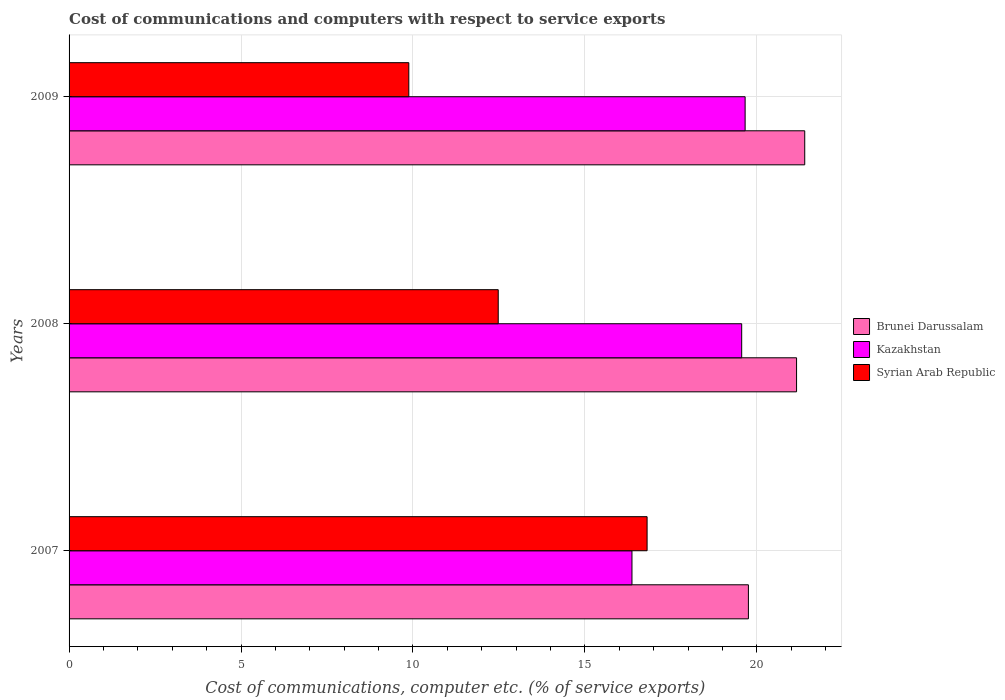Are the number of bars per tick equal to the number of legend labels?
Provide a succinct answer. Yes. Are the number of bars on each tick of the Y-axis equal?
Offer a terse response. Yes. How many bars are there on the 1st tick from the top?
Keep it short and to the point. 3. What is the label of the 3rd group of bars from the top?
Your answer should be very brief. 2007. What is the cost of communications and computers in Kazakhstan in 2009?
Your answer should be compact. 19.66. Across all years, what is the maximum cost of communications and computers in Syrian Arab Republic?
Your answer should be compact. 16.81. Across all years, what is the minimum cost of communications and computers in Brunei Darussalam?
Your answer should be very brief. 19.75. In which year was the cost of communications and computers in Kazakhstan maximum?
Offer a very short reply. 2009. What is the total cost of communications and computers in Brunei Darussalam in the graph?
Give a very brief answer. 62.3. What is the difference between the cost of communications and computers in Brunei Darussalam in 2007 and that in 2008?
Ensure brevity in your answer.  -1.4. What is the difference between the cost of communications and computers in Brunei Darussalam in 2009 and the cost of communications and computers in Syrian Arab Republic in 2008?
Make the answer very short. 8.91. What is the average cost of communications and computers in Kazakhstan per year?
Keep it short and to the point. 18.53. In the year 2009, what is the difference between the cost of communications and computers in Brunei Darussalam and cost of communications and computers in Kazakhstan?
Give a very brief answer. 1.73. What is the ratio of the cost of communications and computers in Brunei Darussalam in 2007 to that in 2008?
Provide a short and direct response. 0.93. What is the difference between the highest and the second highest cost of communications and computers in Syrian Arab Republic?
Provide a short and direct response. 4.33. What is the difference between the highest and the lowest cost of communications and computers in Brunei Darussalam?
Give a very brief answer. 1.64. What does the 3rd bar from the top in 2007 represents?
Offer a very short reply. Brunei Darussalam. What does the 3rd bar from the bottom in 2007 represents?
Provide a short and direct response. Syrian Arab Republic. How many bars are there?
Make the answer very short. 9. How many years are there in the graph?
Your answer should be compact. 3. What is the difference between two consecutive major ticks on the X-axis?
Your answer should be compact. 5. Are the values on the major ticks of X-axis written in scientific E-notation?
Offer a very short reply. No. Does the graph contain grids?
Your answer should be compact. Yes. How many legend labels are there?
Make the answer very short. 3. How are the legend labels stacked?
Ensure brevity in your answer.  Vertical. What is the title of the graph?
Give a very brief answer. Cost of communications and computers with respect to service exports. What is the label or title of the X-axis?
Your answer should be very brief. Cost of communications, computer etc. (% of service exports). What is the label or title of the Y-axis?
Offer a terse response. Years. What is the Cost of communications, computer etc. (% of service exports) in Brunei Darussalam in 2007?
Provide a short and direct response. 19.75. What is the Cost of communications, computer etc. (% of service exports) of Kazakhstan in 2007?
Provide a short and direct response. 16.37. What is the Cost of communications, computer etc. (% of service exports) of Syrian Arab Republic in 2007?
Your answer should be very brief. 16.81. What is the Cost of communications, computer etc. (% of service exports) of Brunei Darussalam in 2008?
Offer a terse response. 21.15. What is the Cost of communications, computer etc. (% of service exports) of Kazakhstan in 2008?
Your response must be concise. 19.56. What is the Cost of communications, computer etc. (% of service exports) in Syrian Arab Republic in 2008?
Provide a short and direct response. 12.48. What is the Cost of communications, computer etc. (% of service exports) of Brunei Darussalam in 2009?
Give a very brief answer. 21.39. What is the Cost of communications, computer etc. (% of service exports) of Kazakhstan in 2009?
Provide a succinct answer. 19.66. What is the Cost of communications, computer etc. (% of service exports) in Syrian Arab Republic in 2009?
Keep it short and to the point. 9.88. Across all years, what is the maximum Cost of communications, computer etc. (% of service exports) of Brunei Darussalam?
Make the answer very short. 21.39. Across all years, what is the maximum Cost of communications, computer etc. (% of service exports) in Kazakhstan?
Provide a short and direct response. 19.66. Across all years, what is the maximum Cost of communications, computer etc. (% of service exports) in Syrian Arab Republic?
Your answer should be very brief. 16.81. Across all years, what is the minimum Cost of communications, computer etc. (% of service exports) in Brunei Darussalam?
Offer a terse response. 19.75. Across all years, what is the minimum Cost of communications, computer etc. (% of service exports) in Kazakhstan?
Make the answer very short. 16.37. Across all years, what is the minimum Cost of communications, computer etc. (% of service exports) of Syrian Arab Republic?
Ensure brevity in your answer.  9.88. What is the total Cost of communications, computer etc. (% of service exports) in Brunei Darussalam in the graph?
Offer a terse response. 62.3. What is the total Cost of communications, computer etc. (% of service exports) of Kazakhstan in the graph?
Make the answer very short. 55.58. What is the total Cost of communications, computer etc. (% of service exports) in Syrian Arab Republic in the graph?
Give a very brief answer. 39.17. What is the difference between the Cost of communications, computer etc. (% of service exports) of Brunei Darussalam in 2007 and that in 2008?
Ensure brevity in your answer.  -1.4. What is the difference between the Cost of communications, computer etc. (% of service exports) in Kazakhstan in 2007 and that in 2008?
Provide a short and direct response. -3.19. What is the difference between the Cost of communications, computer etc. (% of service exports) of Syrian Arab Republic in 2007 and that in 2008?
Ensure brevity in your answer.  4.33. What is the difference between the Cost of communications, computer etc. (% of service exports) in Brunei Darussalam in 2007 and that in 2009?
Provide a short and direct response. -1.64. What is the difference between the Cost of communications, computer etc. (% of service exports) of Kazakhstan in 2007 and that in 2009?
Offer a very short reply. -3.29. What is the difference between the Cost of communications, computer etc. (% of service exports) in Syrian Arab Republic in 2007 and that in 2009?
Give a very brief answer. 6.93. What is the difference between the Cost of communications, computer etc. (% of service exports) of Brunei Darussalam in 2008 and that in 2009?
Make the answer very short. -0.24. What is the difference between the Cost of communications, computer etc. (% of service exports) of Kazakhstan in 2008 and that in 2009?
Your answer should be very brief. -0.1. What is the difference between the Cost of communications, computer etc. (% of service exports) in Syrian Arab Republic in 2008 and that in 2009?
Ensure brevity in your answer.  2.6. What is the difference between the Cost of communications, computer etc. (% of service exports) in Brunei Darussalam in 2007 and the Cost of communications, computer etc. (% of service exports) in Kazakhstan in 2008?
Your response must be concise. 0.2. What is the difference between the Cost of communications, computer etc. (% of service exports) in Brunei Darussalam in 2007 and the Cost of communications, computer etc. (% of service exports) in Syrian Arab Republic in 2008?
Your answer should be compact. 7.27. What is the difference between the Cost of communications, computer etc. (% of service exports) of Kazakhstan in 2007 and the Cost of communications, computer etc. (% of service exports) of Syrian Arab Republic in 2008?
Ensure brevity in your answer.  3.89. What is the difference between the Cost of communications, computer etc. (% of service exports) in Brunei Darussalam in 2007 and the Cost of communications, computer etc. (% of service exports) in Kazakhstan in 2009?
Keep it short and to the point. 0.1. What is the difference between the Cost of communications, computer etc. (% of service exports) of Brunei Darussalam in 2007 and the Cost of communications, computer etc. (% of service exports) of Syrian Arab Republic in 2009?
Give a very brief answer. 9.87. What is the difference between the Cost of communications, computer etc. (% of service exports) of Kazakhstan in 2007 and the Cost of communications, computer etc. (% of service exports) of Syrian Arab Republic in 2009?
Your response must be concise. 6.49. What is the difference between the Cost of communications, computer etc. (% of service exports) of Brunei Darussalam in 2008 and the Cost of communications, computer etc. (% of service exports) of Kazakhstan in 2009?
Offer a very short reply. 1.5. What is the difference between the Cost of communications, computer etc. (% of service exports) in Brunei Darussalam in 2008 and the Cost of communications, computer etc. (% of service exports) in Syrian Arab Republic in 2009?
Give a very brief answer. 11.27. What is the difference between the Cost of communications, computer etc. (% of service exports) of Kazakhstan in 2008 and the Cost of communications, computer etc. (% of service exports) of Syrian Arab Republic in 2009?
Offer a very short reply. 9.68. What is the average Cost of communications, computer etc. (% of service exports) in Brunei Darussalam per year?
Your answer should be very brief. 20.77. What is the average Cost of communications, computer etc. (% of service exports) in Kazakhstan per year?
Your response must be concise. 18.53. What is the average Cost of communications, computer etc. (% of service exports) of Syrian Arab Republic per year?
Provide a succinct answer. 13.06. In the year 2007, what is the difference between the Cost of communications, computer etc. (% of service exports) of Brunei Darussalam and Cost of communications, computer etc. (% of service exports) of Kazakhstan?
Provide a succinct answer. 3.39. In the year 2007, what is the difference between the Cost of communications, computer etc. (% of service exports) of Brunei Darussalam and Cost of communications, computer etc. (% of service exports) of Syrian Arab Republic?
Offer a terse response. 2.95. In the year 2007, what is the difference between the Cost of communications, computer etc. (% of service exports) in Kazakhstan and Cost of communications, computer etc. (% of service exports) in Syrian Arab Republic?
Your answer should be very brief. -0.44. In the year 2008, what is the difference between the Cost of communications, computer etc. (% of service exports) of Brunei Darussalam and Cost of communications, computer etc. (% of service exports) of Kazakhstan?
Offer a very short reply. 1.6. In the year 2008, what is the difference between the Cost of communications, computer etc. (% of service exports) in Brunei Darussalam and Cost of communications, computer etc. (% of service exports) in Syrian Arab Republic?
Your answer should be very brief. 8.67. In the year 2008, what is the difference between the Cost of communications, computer etc. (% of service exports) in Kazakhstan and Cost of communications, computer etc. (% of service exports) in Syrian Arab Republic?
Your answer should be very brief. 7.08. In the year 2009, what is the difference between the Cost of communications, computer etc. (% of service exports) in Brunei Darussalam and Cost of communications, computer etc. (% of service exports) in Kazakhstan?
Give a very brief answer. 1.73. In the year 2009, what is the difference between the Cost of communications, computer etc. (% of service exports) in Brunei Darussalam and Cost of communications, computer etc. (% of service exports) in Syrian Arab Republic?
Provide a short and direct response. 11.51. In the year 2009, what is the difference between the Cost of communications, computer etc. (% of service exports) in Kazakhstan and Cost of communications, computer etc. (% of service exports) in Syrian Arab Republic?
Keep it short and to the point. 9.78. What is the ratio of the Cost of communications, computer etc. (% of service exports) of Brunei Darussalam in 2007 to that in 2008?
Provide a succinct answer. 0.93. What is the ratio of the Cost of communications, computer etc. (% of service exports) in Kazakhstan in 2007 to that in 2008?
Your answer should be very brief. 0.84. What is the ratio of the Cost of communications, computer etc. (% of service exports) of Syrian Arab Republic in 2007 to that in 2008?
Your answer should be very brief. 1.35. What is the ratio of the Cost of communications, computer etc. (% of service exports) of Brunei Darussalam in 2007 to that in 2009?
Keep it short and to the point. 0.92. What is the ratio of the Cost of communications, computer etc. (% of service exports) of Kazakhstan in 2007 to that in 2009?
Ensure brevity in your answer.  0.83. What is the ratio of the Cost of communications, computer etc. (% of service exports) of Syrian Arab Republic in 2007 to that in 2009?
Your answer should be very brief. 1.7. What is the ratio of the Cost of communications, computer etc. (% of service exports) of Brunei Darussalam in 2008 to that in 2009?
Provide a succinct answer. 0.99. What is the ratio of the Cost of communications, computer etc. (% of service exports) in Kazakhstan in 2008 to that in 2009?
Keep it short and to the point. 0.99. What is the ratio of the Cost of communications, computer etc. (% of service exports) in Syrian Arab Republic in 2008 to that in 2009?
Your answer should be very brief. 1.26. What is the difference between the highest and the second highest Cost of communications, computer etc. (% of service exports) in Brunei Darussalam?
Provide a succinct answer. 0.24. What is the difference between the highest and the second highest Cost of communications, computer etc. (% of service exports) of Kazakhstan?
Your answer should be compact. 0.1. What is the difference between the highest and the second highest Cost of communications, computer etc. (% of service exports) in Syrian Arab Republic?
Offer a terse response. 4.33. What is the difference between the highest and the lowest Cost of communications, computer etc. (% of service exports) in Brunei Darussalam?
Your response must be concise. 1.64. What is the difference between the highest and the lowest Cost of communications, computer etc. (% of service exports) of Kazakhstan?
Your response must be concise. 3.29. What is the difference between the highest and the lowest Cost of communications, computer etc. (% of service exports) in Syrian Arab Republic?
Ensure brevity in your answer.  6.93. 